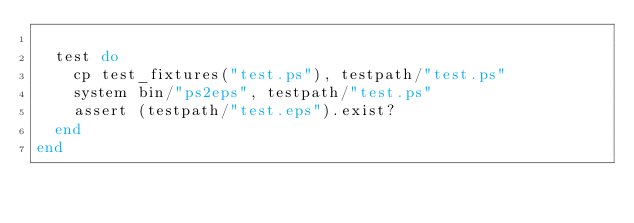Convert code to text. <code><loc_0><loc_0><loc_500><loc_500><_Ruby_>
  test do
    cp test_fixtures("test.ps"), testpath/"test.ps"
    system bin/"ps2eps", testpath/"test.ps"
    assert (testpath/"test.eps").exist?
  end
end
</code> 